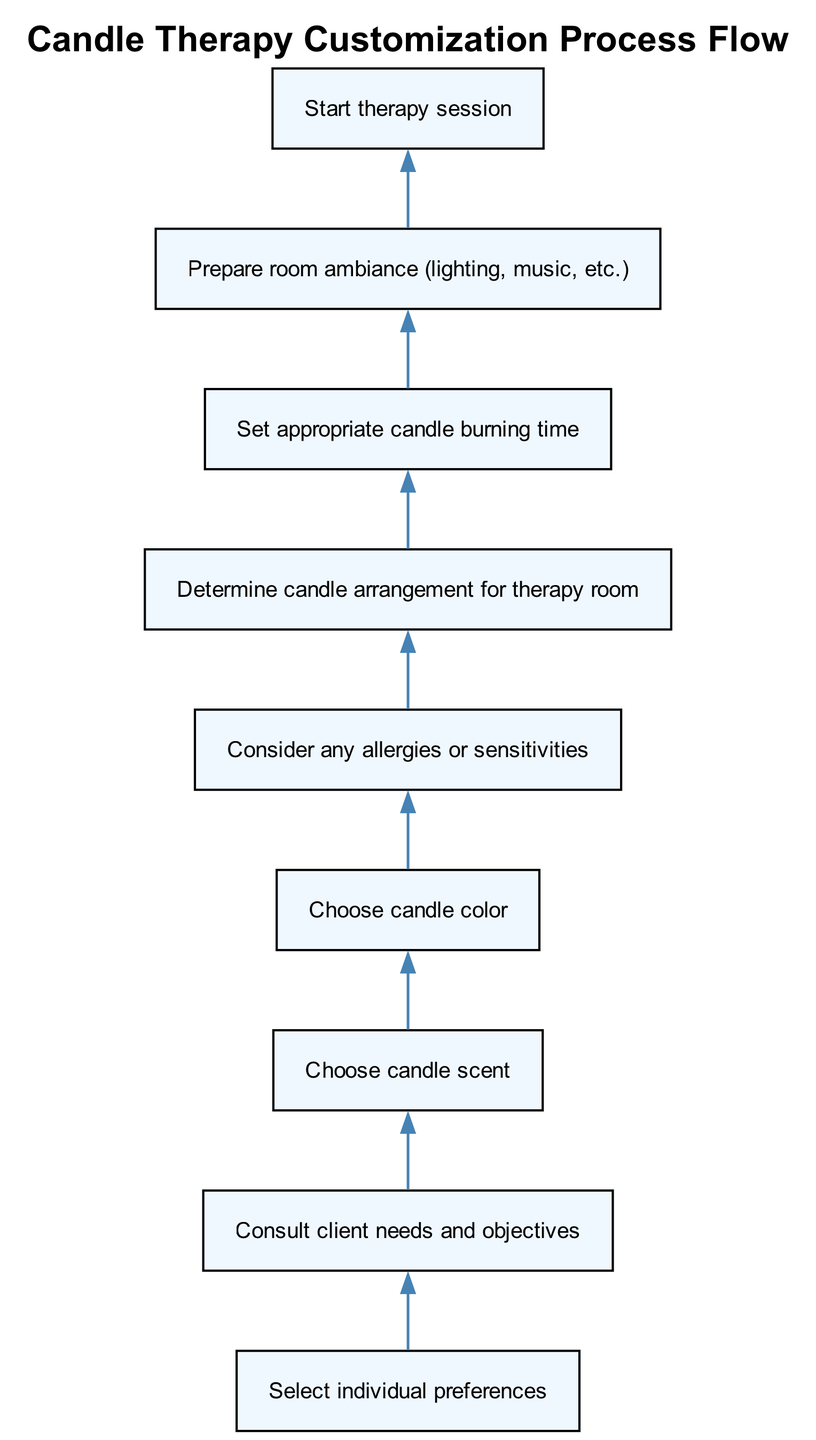What is the first step in the candle therapy customization process? The first step in the flowchart is "Select individual preferences," which is the initial node before any other actions occur.
Answer: Select individual preferences How many nodes are there in total in the diagram? The diagram shows a total of 8 nodes that represent different steps in the candle therapy process.
Answer: 8 What follows after "Choose candle color"? After "Choose candle color," the next step in the process is "Consider any allergies or sensitivities," indicating a progression in decision-making based on the color choice.
Answer: Consider any allergies or sensitivities Which step comes before preparing the room ambiance? The step that comes immediately before "Prepare room ambiance" is "Set appropriate candle burning time," highlighting the sequential nature of the custom therapeutic setup.
Answer: Set appropriate candle burning time If a client has allergies, what step should be considered? If the client has allergies, the step to consider is "Consider any allergies or sensitivities," which is crucial to ensure their safety during the therapy session.
Answer: Consider any allergies or sensitivities What is the last step in the procedure? The last step as outlined in the flowchart is "Start therapy session," indicating the conclusion of the preparation steps leading into the actual therapy experience.
Answer: Start therapy session What is the main function of the "Consult client needs and objectives" step? The main function is to gather essential information from the client to tailor the therapy to their specific desires and necessities, guiding the subsequent choices.
Answer: To gather essential information In which order do the steps occur after selecting individual preferences? The order is: "Consult client needs and objectives," followed by "Choose candle scent," "Choose candle color," "Consider any allergies or sensitivities," "Determine candle arrangement for therapy room," and "Set appropriate candle burning time," emphasizing a logical flow toward the therapy session.
Answer: Consult, Choose scent, Choose color, Consider allergies, Arrange, Set time 